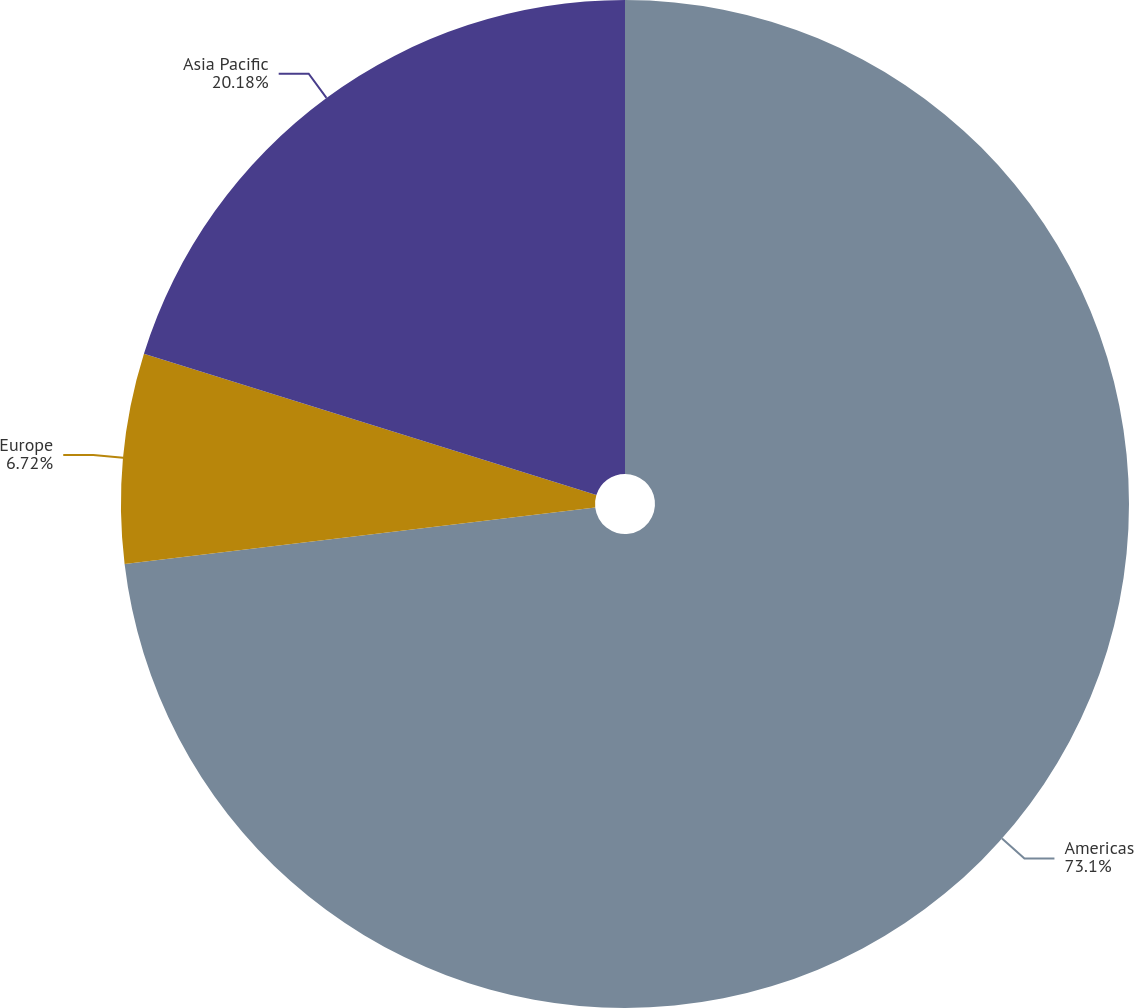<chart> <loc_0><loc_0><loc_500><loc_500><pie_chart><fcel>Americas<fcel>Europe<fcel>Asia Pacific<nl><fcel>73.1%<fcel>6.72%<fcel>20.18%<nl></chart> 